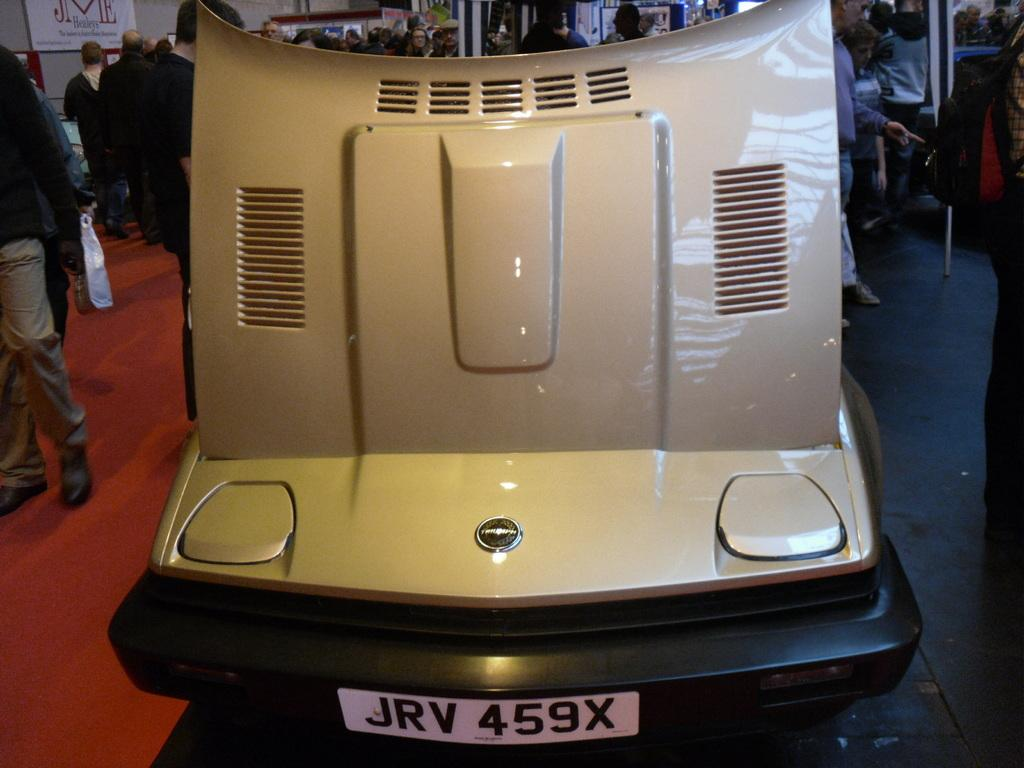What is the main subject in the foreground of the image? There is a vehicle in the foreground of the image. What are the people in the background of the image doing? There are persons standing and walking in the background of the image. What type of structures can be seen in the image? There are posts and poles visible in the image. What type of wren can be seen perched on the vehicle in the image? There is no wren present in the image; it only features a vehicle, persons, posts, and poles. How many fans are visible in the image? There are no fans visible in the image. 